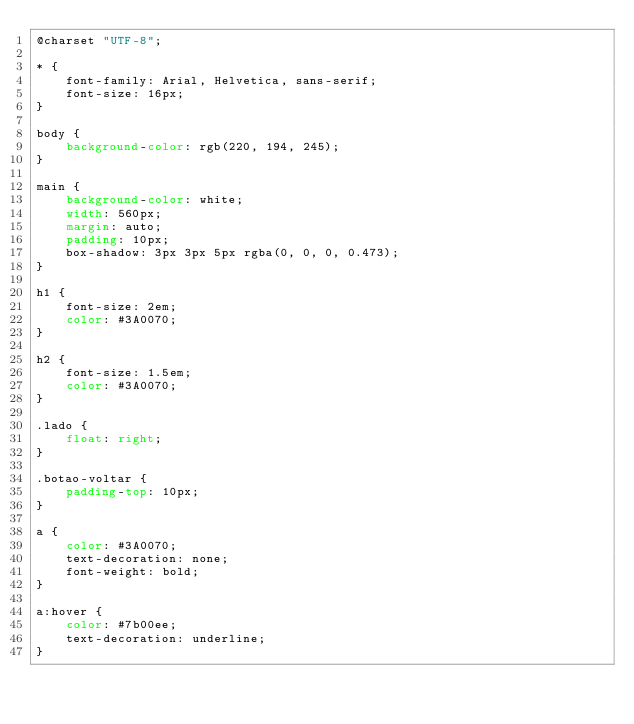Convert code to text. <code><loc_0><loc_0><loc_500><loc_500><_CSS_>@charset "UTF-8";

* {
    font-family: Arial, Helvetica, sans-serif;
    font-size: 16px;
}

body {
    background-color: rgb(220, 194, 245);
}

main {
    background-color: white;
    width: 560px;
    margin: auto;
    padding: 10px;
    box-shadow: 3px 3px 5px rgba(0, 0, 0, 0.473);
}

h1 {
    font-size: 2em;
    color: #3A0070;
}

h2 {
    font-size: 1.5em;
    color: #3A0070;
}

.lado {
    float: right;
}

.botao-voltar {
    padding-top: 10px;
}

a {
    color: #3A0070;
    text-decoration: none;
    font-weight: bold;
}

a:hover {
    color: #7b00ee;
    text-decoration: underline;
}</code> 